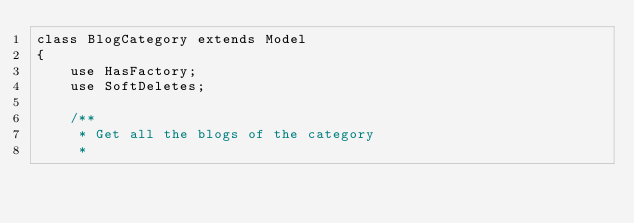<code> <loc_0><loc_0><loc_500><loc_500><_PHP_>class BlogCategory extends Model
{
    use HasFactory;
    use SoftDeletes;

    /**
     * Get all the blogs of the category
     *</code> 